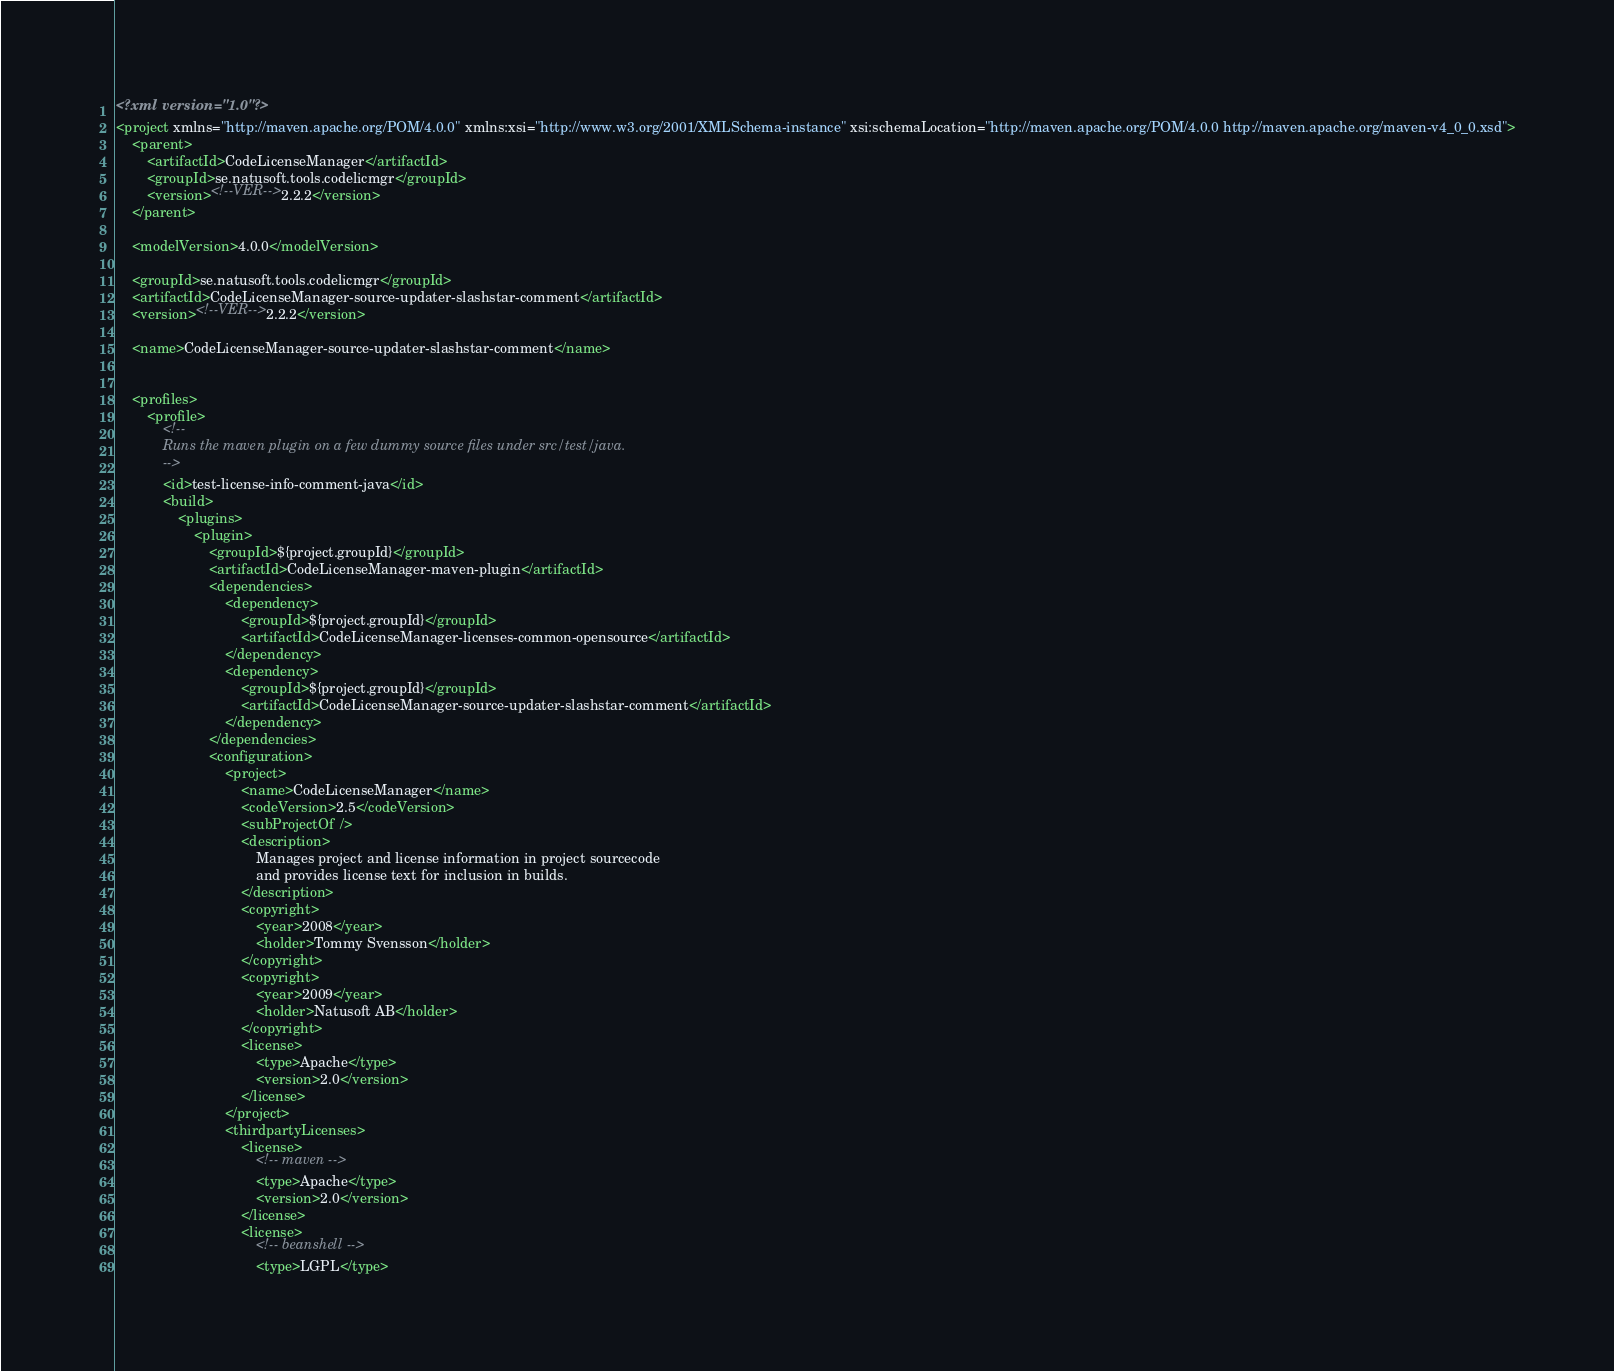Convert code to text. <code><loc_0><loc_0><loc_500><loc_500><_XML_><?xml version="1.0"?>
<project xmlns="http://maven.apache.org/POM/4.0.0" xmlns:xsi="http://www.w3.org/2001/XMLSchema-instance" xsi:schemaLocation="http://maven.apache.org/POM/4.0.0 http://maven.apache.org/maven-v4_0_0.xsd">
    <parent>
        <artifactId>CodeLicenseManager</artifactId>
        <groupId>se.natusoft.tools.codelicmgr</groupId>
        <version><!--VER-->2.2.2</version>
    </parent>

    <modelVersion>4.0.0</modelVersion>

    <groupId>se.natusoft.tools.codelicmgr</groupId>
    <artifactId>CodeLicenseManager-source-updater-slashstar-comment</artifactId>
    <version><!--VER-->2.2.2</version>

    <name>CodeLicenseManager-source-updater-slashstar-comment</name>


    <profiles>
        <profile>
            <!--
            Runs the maven plugin on a few dummy source files under src/test/java.
            -->
            <id>test-license-info-comment-java</id>
            <build>
                <plugins>
                    <plugin>
                        <groupId>${project.groupId}</groupId>
                        <artifactId>CodeLicenseManager-maven-plugin</artifactId>
                        <dependencies>
                            <dependency>
                                <groupId>${project.groupId}</groupId>
                                <artifactId>CodeLicenseManager-licenses-common-opensource</artifactId>
                            </dependency>
                            <dependency>
                                <groupId>${project.groupId}</groupId>
                                <artifactId>CodeLicenseManager-source-updater-slashstar-comment</artifactId>
                            </dependency>
                        </dependencies>
                        <configuration>
                            <project>
                                <name>CodeLicenseManager</name>
                                <codeVersion>2.5</codeVersion>
                                <subProjectOf />
                                <description>
                                    Manages project and license information in project sourcecode
                                    and provides license text for inclusion in builds.
                                </description>
                                <copyright>
                                    <year>2008</year>
                                    <holder>Tommy Svensson</holder>
                                </copyright>
                                <copyright>
                                    <year>2009</year>
                                    <holder>Natusoft AB</holder>
                                </copyright>
                                <license>
                                    <type>Apache</type>
                                    <version>2.0</version>
                                </license>
                            </project>
                            <thirdpartyLicenses>
                                <license>
                                    <!-- maven -->
                                    <type>Apache</type>
                                    <version>2.0</version>
                                </license>
                                <license>
                                    <!-- beanshell -->
                                    <type>LGPL</type></code> 